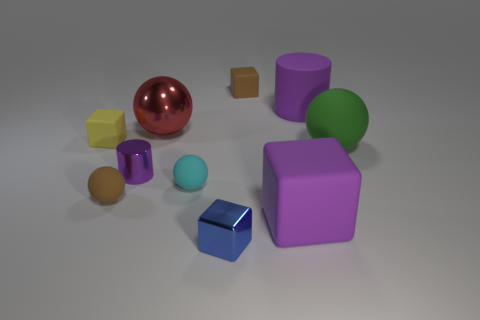Are there the same number of purple rubber things behind the tiny brown rubber block and small purple metallic cylinders that are in front of the brown rubber sphere?
Your answer should be compact. Yes. What material is the small cyan ball?
Keep it short and to the point. Rubber. There is a ball that is to the left of the tiny purple thing; what is it made of?
Keep it short and to the point. Rubber. Is there anything else that has the same material as the large purple block?
Your answer should be very brief. Yes. Is the number of cyan rubber things that are behind the tiny shiny cylinder greater than the number of red rubber objects?
Your answer should be compact. No. There is a tiny cube on the left side of the cylinder that is in front of the tiny yellow object; is there a big green object that is to the left of it?
Offer a terse response. No. Are there any matte blocks in front of the green ball?
Give a very brief answer. Yes. How many small things have the same color as the metallic block?
Give a very brief answer. 0. The blue block that is made of the same material as the small purple cylinder is what size?
Provide a short and direct response. Small. What size is the block left of the purple cylinder that is left of the small rubber block that is behind the small yellow rubber thing?
Offer a very short reply. Small. 